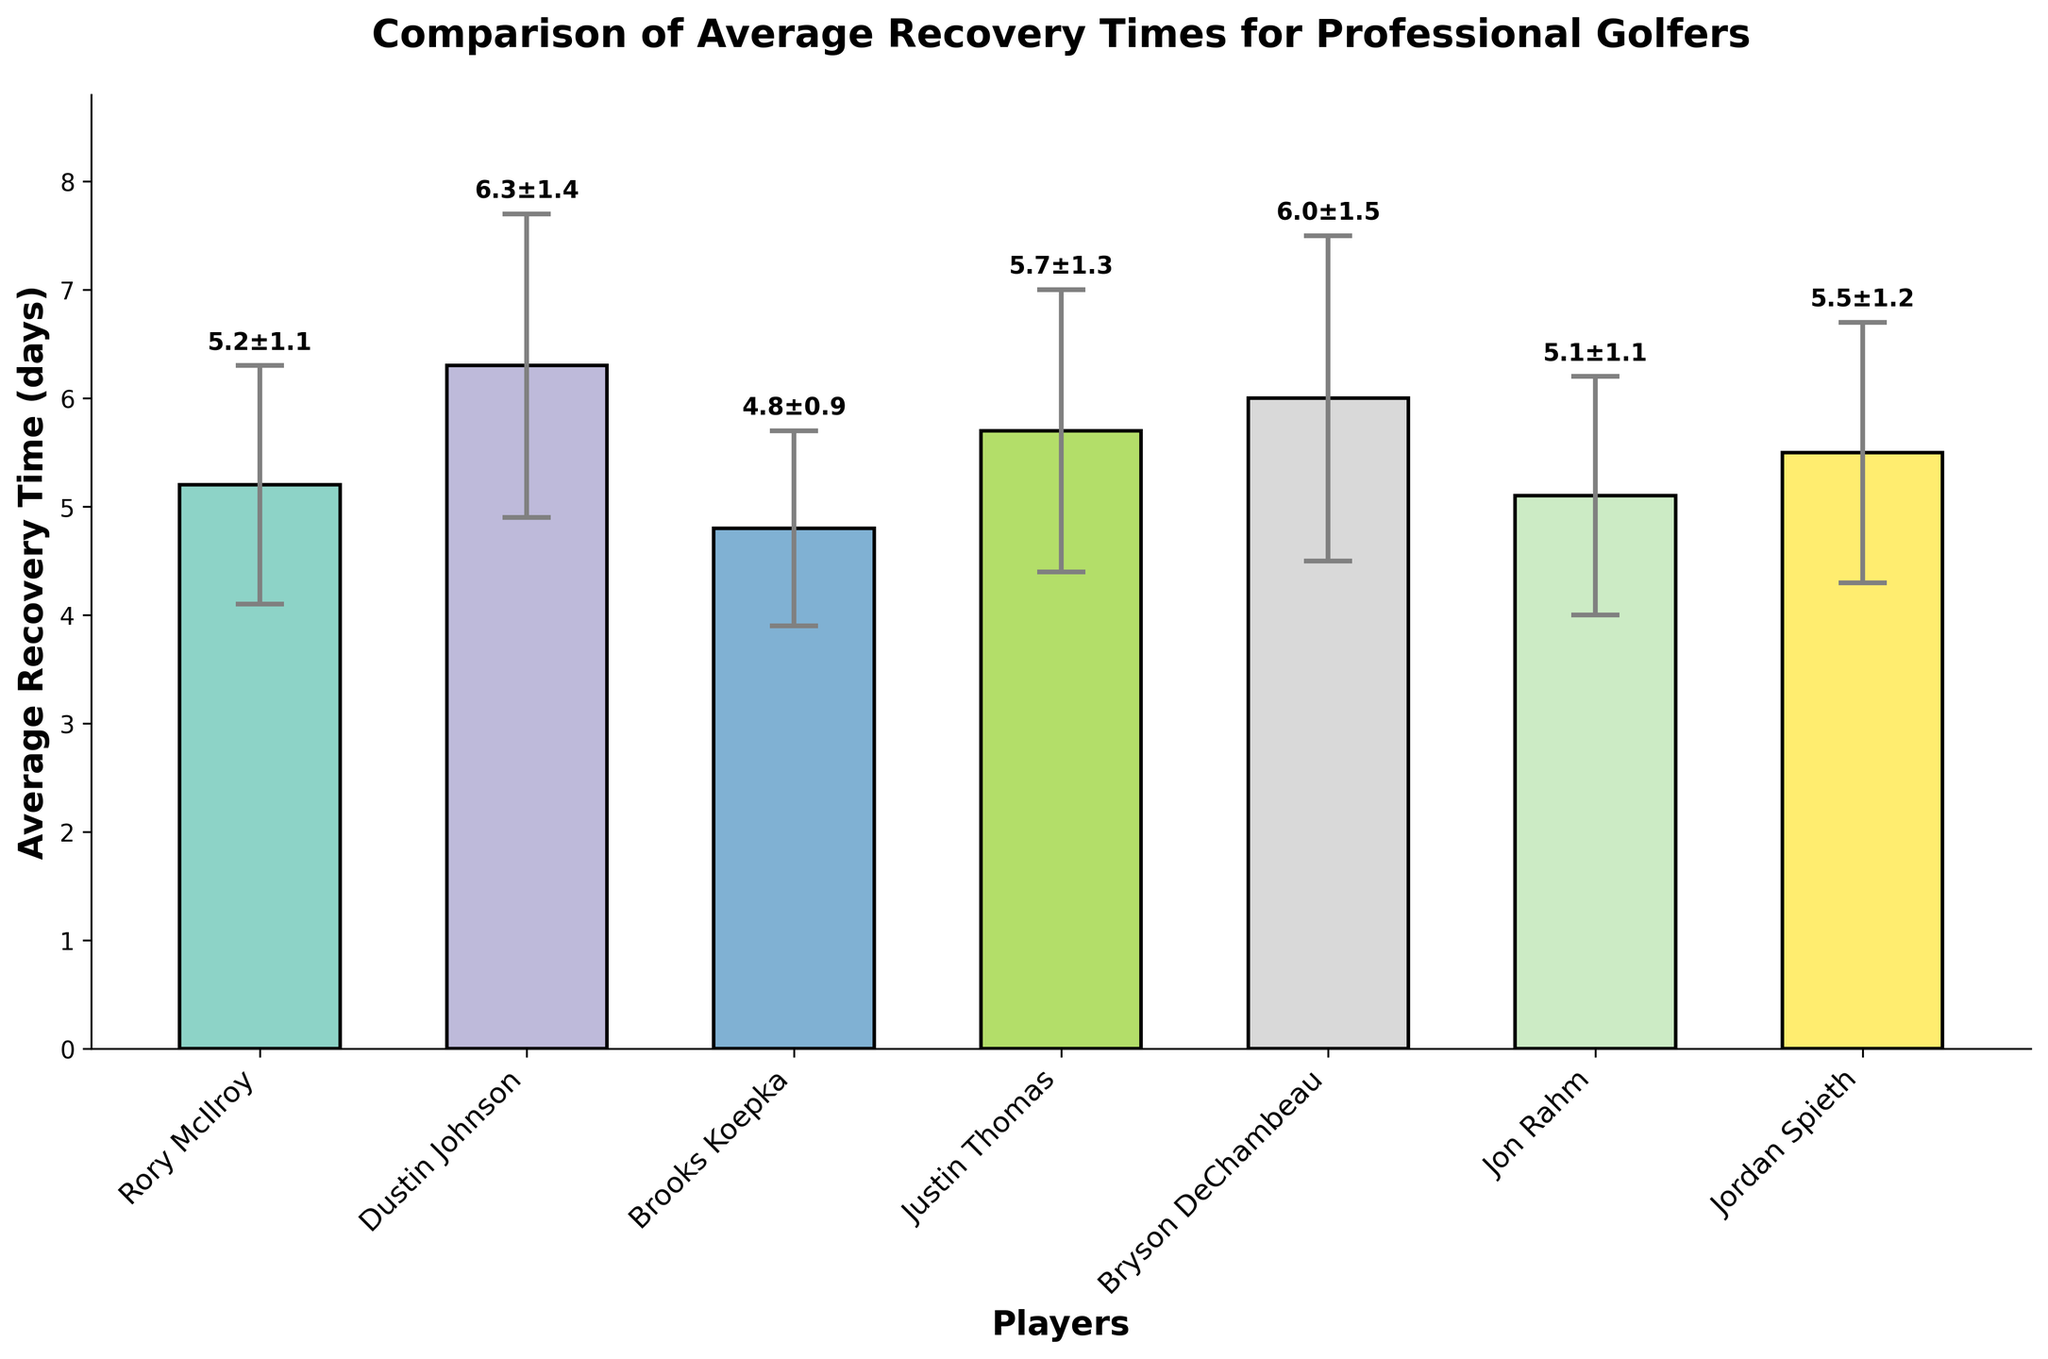How many players are compared in the plot? Count the number of bars in the figure. There are seven bars corresponding to seven players.
Answer: Seven What is the title of the plot? The title is usually displayed at the top of the figure.
Answer: Comparison of Average Recovery Times for Professional Golfers Which player has the shortest average recovery time? Identify the player with the shortest bar in the plot representing the average recovery time.
Answer: Brooks Koepka Who has the largest variability in recovery time? Look for the player whose error bar is the longest (indicating the largest standard deviation).
Answer: Bryson DeChambeau What is the difference in average recovery time between Dustin Johnson and Jon Rahm? Subtract Jon Rahm's average recovery time (5.1 days) from Dustin Johnson's average recovery time (6.3 days). 6.3 - 5.1 = 1.2 days.
Answer: 1.2 days Which two players have the same standard deviation in their recovery times? Identify players whose error bars have the same length. Rory McIlroy and Jon Rahm both have a standard deviation of 1.1 days.
Answer: Rory McIlroy and Jon Rahm What is the combined recovery time for Rory McIlroy and Jordan Spieth? Add the average recovery times of Rory McIlroy (5.2 days) and Jordan Spieth (5.5 days). 5.2 + 5.5 = 10.7 days.
Answer: 10.7 days Who has the second longest average recovery time? Identify the second tallest bar in the figure. Bryson DeChambeau has the second longest average recovery time.
Answer: Bryson DeChambeau Which player has exactly 1.2 days' variability in recovery time? Identify the player whose error bar represents a deviation of 1.2 days. Jordan Spieth has a standard deviation of 1.2 days.
Answer: Jordan Spieth Compare the recovery times of Brooks Koepka and Justin Thomas. Who recovers faster on average, and by how many days? Brooks Koepka (4.8 days) has a shorter average recovery time compared to Justin Thomas (5.7 days). Subtract 4.8 from 5.7 to find the difference. 5.7 - 4.8 = 0.9 days.
Answer: Brooks Koepka recovers faster by 0.9 days 